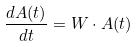<formula> <loc_0><loc_0><loc_500><loc_500>\frac { d A ( t ) } { d t } = W \cdot A ( t )</formula> 